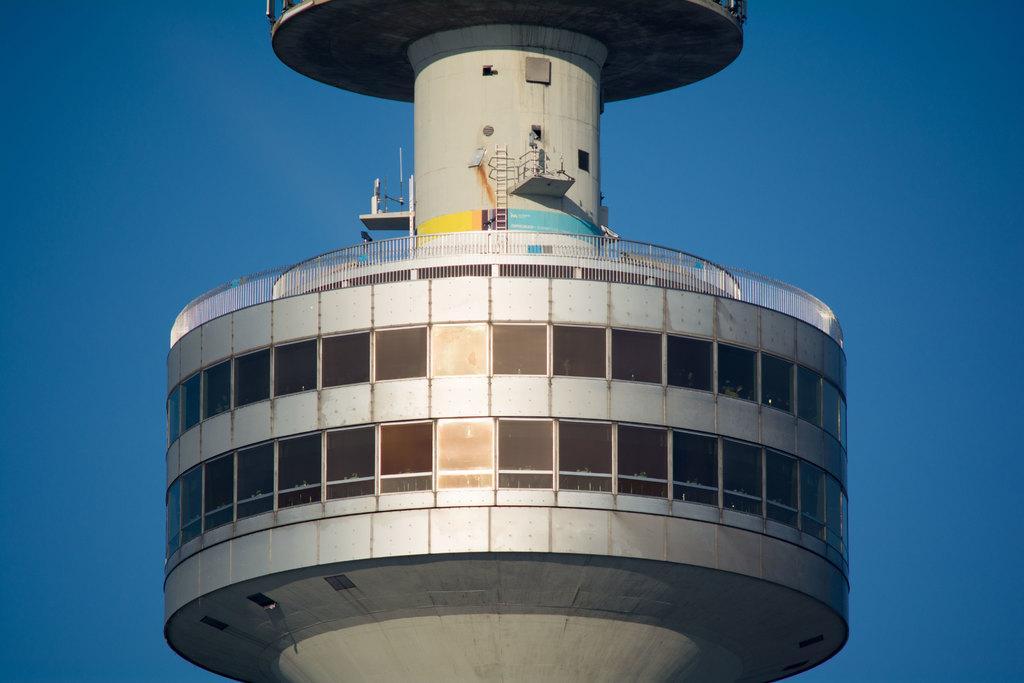Can you describe this image briefly? In this image we can see the tower with some windows. On the backside we can see the sky. 